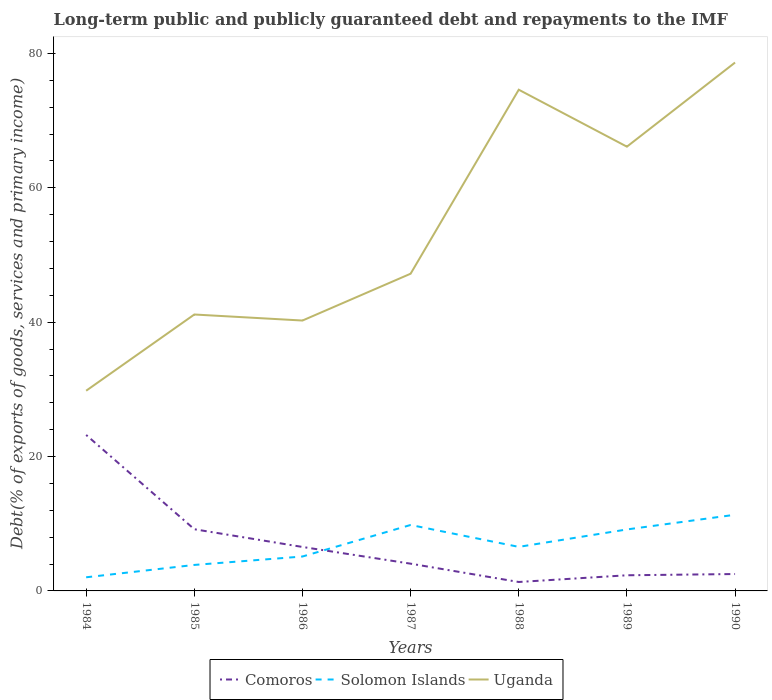How many different coloured lines are there?
Offer a very short reply. 3. Does the line corresponding to Uganda intersect with the line corresponding to Comoros?
Keep it short and to the point. No. Is the number of lines equal to the number of legend labels?
Give a very brief answer. Yes. Across all years, what is the maximum debt and repayments in Uganda?
Offer a very short reply. 29.8. In which year was the debt and repayments in Solomon Islands maximum?
Offer a very short reply. 1984. What is the total debt and repayments in Comoros in the graph?
Your answer should be very brief. 14.03. What is the difference between the highest and the second highest debt and repayments in Solomon Islands?
Ensure brevity in your answer.  9.31. What is the difference between two consecutive major ticks on the Y-axis?
Ensure brevity in your answer.  20. Are the values on the major ticks of Y-axis written in scientific E-notation?
Offer a very short reply. No. Does the graph contain grids?
Ensure brevity in your answer.  No. What is the title of the graph?
Keep it short and to the point. Long-term public and publicly guaranteed debt and repayments to the IMF. What is the label or title of the Y-axis?
Make the answer very short. Debt(% of exports of goods, services and primary income). What is the Debt(% of exports of goods, services and primary income) of Comoros in 1984?
Keep it short and to the point. 23.21. What is the Debt(% of exports of goods, services and primary income) in Solomon Islands in 1984?
Offer a very short reply. 2.03. What is the Debt(% of exports of goods, services and primary income) in Uganda in 1984?
Your response must be concise. 29.8. What is the Debt(% of exports of goods, services and primary income) in Comoros in 1985?
Provide a succinct answer. 9.18. What is the Debt(% of exports of goods, services and primary income) of Solomon Islands in 1985?
Keep it short and to the point. 3.87. What is the Debt(% of exports of goods, services and primary income) of Uganda in 1985?
Your answer should be very brief. 41.14. What is the Debt(% of exports of goods, services and primary income) of Comoros in 1986?
Offer a very short reply. 6.54. What is the Debt(% of exports of goods, services and primary income) of Solomon Islands in 1986?
Make the answer very short. 5.12. What is the Debt(% of exports of goods, services and primary income) of Uganda in 1986?
Your answer should be very brief. 40.24. What is the Debt(% of exports of goods, services and primary income) in Comoros in 1987?
Give a very brief answer. 4.06. What is the Debt(% of exports of goods, services and primary income) in Solomon Islands in 1987?
Your answer should be compact. 9.82. What is the Debt(% of exports of goods, services and primary income) of Uganda in 1987?
Provide a short and direct response. 47.21. What is the Debt(% of exports of goods, services and primary income) of Comoros in 1988?
Make the answer very short. 1.33. What is the Debt(% of exports of goods, services and primary income) of Solomon Islands in 1988?
Your answer should be very brief. 6.56. What is the Debt(% of exports of goods, services and primary income) in Uganda in 1988?
Provide a short and direct response. 74.6. What is the Debt(% of exports of goods, services and primary income) of Comoros in 1989?
Provide a succinct answer. 2.33. What is the Debt(% of exports of goods, services and primary income) in Solomon Islands in 1989?
Provide a short and direct response. 9.15. What is the Debt(% of exports of goods, services and primary income) of Uganda in 1989?
Offer a very short reply. 66.12. What is the Debt(% of exports of goods, services and primary income) of Comoros in 1990?
Provide a succinct answer. 2.51. What is the Debt(% of exports of goods, services and primary income) of Solomon Islands in 1990?
Keep it short and to the point. 11.34. What is the Debt(% of exports of goods, services and primary income) of Uganda in 1990?
Your answer should be compact. 78.64. Across all years, what is the maximum Debt(% of exports of goods, services and primary income) in Comoros?
Your response must be concise. 23.21. Across all years, what is the maximum Debt(% of exports of goods, services and primary income) of Solomon Islands?
Your answer should be very brief. 11.34. Across all years, what is the maximum Debt(% of exports of goods, services and primary income) in Uganda?
Offer a terse response. 78.64. Across all years, what is the minimum Debt(% of exports of goods, services and primary income) in Comoros?
Make the answer very short. 1.33. Across all years, what is the minimum Debt(% of exports of goods, services and primary income) of Solomon Islands?
Your answer should be very brief. 2.03. Across all years, what is the minimum Debt(% of exports of goods, services and primary income) in Uganda?
Provide a short and direct response. 29.8. What is the total Debt(% of exports of goods, services and primary income) of Comoros in the graph?
Make the answer very short. 49.16. What is the total Debt(% of exports of goods, services and primary income) of Solomon Islands in the graph?
Ensure brevity in your answer.  47.87. What is the total Debt(% of exports of goods, services and primary income) in Uganda in the graph?
Provide a succinct answer. 377.74. What is the difference between the Debt(% of exports of goods, services and primary income) in Comoros in 1984 and that in 1985?
Keep it short and to the point. 14.03. What is the difference between the Debt(% of exports of goods, services and primary income) of Solomon Islands in 1984 and that in 1985?
Your response must be concise. -1.84. What is the difference between the Debt(% of exports of goods, services and primary income) of Uganda in 1984 and that in 1985?
Offer a terse response. -11.34. What is the difference between the Debt(% of exports of goods, services and primary income) in Comoros in 1984 and that in 1986?
Make the answer very short. 16.67. What is the difference between the Debt(% of exports of goods, services and primary income) in Solomon Islands in 1984 and that in 1986?
Ensure brevity in your answer.  -3.09. What is the difference between the Debt(% of exports of goods, services and primary income) of Uganda in 1984 and that in 1986?
Offer a very short reply. -10.45. What is the difference between the Debt(% of exports of goods, services and primary income) of Comoros in 1984 and that in 1987?
Ensure brevity in your answer.  19.16. What is the difference between the Debt(% of exports of goods, services and primary income) in Solomon Islands in 1984 and that in 1987?
Ensure brevity in your answer.  -7.79. What is the difference between the Debt(% of exports of goods, services and primary income) in Uganda in 1984 and that in 1987?
Make the answer very short. -17.42. What is the difference between the Debt(% of exports of goods, services and primary income) in Comoros in 1984 and that in 1988?
Offer a very short reply. 21.88. What is the difference between the Debt(% of exports of goods, services and primary income) in Solomon Islands in 1984 and that in 1988?
Provide a succinct answer. -4.53. What is the difference between the Debt(% of exports of goods, services and primary income) in Uganda in 1984 and that in 1988?
Keep it short and to the point. -44.8. What is the difference between the Debt(% of exports of goods, services and primary income) in Comoros in 1984 and that in 1989?
Your answer should be very brief. 20.88. What is the difference between the Debt(% of exports of goods, services and primary income) of Solomon Islands in 1984 and that in 1989?
Offer a very short reply. -7.12. What is the difference between the Debt(% of exports of goods, services and primary income) of Uganda in 1984 and that in 1989?
Provide a short and direct response. -36.32. What is the difference between the Debt(% of exports of goods, services and primary income) of Comoros in 1984 and that in 1990?
Your answer should be very brief. 20.7. What is the difference between the Debt(% of exports of goods, services and primary income) of Solomon Islands in 1984 and that in 1990?
Your answer should be compact. -9.31. What is the difference between the Debt(% of exports of goods, services and primary income) in Uganda in 1984 and that in 1990?
Keep it short and to the point. -48.84. What is the difference between the Debt(% of exports of goods, services and primary income) in Comoros in 1985 and that in 1986?
Provide a short and direct response. 2.64. What is the difference between the Debt(% of exports of goods, services and primary income) in Solomon Islands in 1985 and that in 1986?
Make the answer very short. -1.25. What is the difference between the Debt(% of exports of goods, services and primary income) of Uganda in 1985 and that in 1986?
Keep it short and to the point. 0.9. What is the difference between the Debt(% of exports of goods, services and primary income) of Comoros in 1985 and that in 1987?
Make the answer very short. 5.12. What is the difference between the Debt(% of exports of goods, services and primary income) of Solomon Islands in 1985 and that in 1987?
Offer a very short reply. -5.95. What is the difference between the Debt(% of exports of goods, services and primary income) in Uganda in 1985 and that in 1987?
Your response must be concise. -6.07. What is the difference between the Debt(% of exports of goods, services and primary income) of Comoros in 1985 and that in 1988?
Offer a terse response. 7.85. What is the difference between the Debt(% of exports of goods, services and primary income) in Solomon Islands in 1985 and that in 1988?
Offer a terse response. -2.69. What is the difference between the Debt(% of exports of goods, services and primary income) in Uganda in 1985 and that in 1988?
Your answer should be compact. -33.46. What is the difference between the Debt(% of exports of goods, services and primary income) of Comoros in 1985 and that in 1989?
Keep it short and to the point. 6.85. What is the difference between the Debt(% of exports of goods, services and primary income) in Solomon Islands in 1985 and that in 1989?
Give a very brief answer. -5.28. What is the difference between the Debt(% of exports of goods, services and primary income) in Uganda in 1985 and that in 1989?
Provide a succinct answer. -24.98. What is the difference between the Debt(% of exports of goods, services and primary income) of Comoros in 1985 and that in 1990?
Provide a short and direct response. 6.67. What is the difference between the Debt(% of exports of goods, services and primary income) of Solomon Islands in 1985 and that in 1990?
Your answer should be very brief. -7.47. What is the difference between the Debt(% of exports of goods, services and primary income) in Uganda in 1985 and that in 1990?
Your answer should be very brief. -37.5. What is the difference between the Debt(% of exports of goods, services and primary income) of Comoros in 1986 and that in 1987?
Keep it short and to the point. 2.49. What is the difference between the Debt(% of exports of goods, services and primary income) of Solomon Islands in 1986 and that in 1987?
Your answer should be compact. -4.69. What is the difference between the Debt(% of exports of goods, services and primary income) in Uganda in 1986 and that in 1987?
Your answer should be very brief. -6.97. What is the difference between the Debt(% of exports of goods, services and primary income) in Comoros in 1986 and that in 1988?
Offer a very short reply. 5.21. What is the difference between the Debt(% of exports of goods, services and primary income) of Solomon Islands in 1986 and that in 1988?
Provide a short and direct response. -1.43. What is the difference between the Debt(% of exports of goods, services and primary income) in Uganda in 1986 and that in 1988?
Your answer should be very brief. -34.35. What is the difference between the Debt(% of exports of goods, services and primary income) of Comoros in 1986 and that in 1989?
Keep it short and to the point. 4.21. What is the difference between the Debt(% of exports of goods, services and primary income) in Solomon Islands in 1986 and that in 1989?
Your answer should be compact. -4.03. What is the difference between the Debt(% of exports of goods, services and primary income) of Uganda in 1986 and that in 1989?
Provide a succinct answer. -25.88. What is the difference between the Debt(% of exports of goods, services and primary income) in Comoros in 1986 and that in 1990?
Provide a short and direct response. 4.03. What is the difference between the Debt(% of exports of goods, services and primary income) of Solomon Islands in 1986 and that in 1990?
Give a very brief answer. -6.22. What is the difference between the Debt(% of exports of goods, services and primary income) in Uganda in 1986 and that in 1990?
Your response must be concise. -38.4. What is the difference between the Debt(% of exports of goods, services and primary income) of Comoros in 1987 and that in 1988?
Offer a terse response. 2.73. What is the difference between the Debt(% of exports of goods, services and primary income) of Solomon Islands in 1987 and that in 1988?
Offer a terse response. 3.26. What is the difference between the Debt(% of exports of goods, services and primary income) of Uganda in 1987 and that in 1988?
Your answer should be compact. -27.39. What is the difference between the Debt(% of exports of goods, services and primary income) in Comoros in 1987 and that in 1989?
Your answer should be very brief. 1.73. What is the difference between the Debt(% of exports of goods, services and primary income) in Solomon Islands in 1987 and that in 1989?
Your answer should be very brief. 0.67. What is the difference between the Debt(% of exports of goods, services and primary income) of Uganda in 1987 and that in 1989?
Make the answer very short. -18.91. What is the difference between the Debt(% of exports of goods, services and primary income) of Comoros in 1987 and that in 1990?
Keep it short and to the point. 1.54. What is the difference between the Debt(% of exports of goods, services and primary income) of Solomon Islands in 1987 and that in 1990?
Keep it short and to the point. -1.52. What is the difference between the Debt(% of exports of goods, services and primary income) in Uganda in 1987 and that in 1990?
Provide a succinct answer. -31.43. What is the difference between the Debt(% of exports of goods, services and primary income) of Comoros in 1988 and that in 1989?
Your response must be concise. -1. What is the difference between the Debt(% of exports of goods, services and primary income) of Solomon Islands in 1988 and that in 1989?
Offer a terse response. -2.59. What is the difference between the Debt(% of exports of goods, services and primary income) in Uganda in 1988 and that in 1989?
Make the answer very short. 8.48. What is the difference between the Debt(% of exports of goods, services and primary income) of Comoros in 1988 and that in 1990?
Ensure brevity in your answer.  -1.18. What is the difference between the Debt(% of exports of goods, services and primary income) of Solomon Islands in 1988 and that in 1990?
Offer a very short reply. -4.78. What is the difference between the Debt(% of exports of goods, services and primary income) of Uganda in 1988 and that in 1990?
Offer a terse response. -4.04. What is the difference between the Debt(% of exports of goods, services and primary income) of Comoros in 1989 and that in 1990?
Your answer should be very brief. -0.19. What is the difference between the Debt(% of exports of goods, services and primary income) in Solomon Islands in 1989 and that in 1990?
Provide a succinct answer. -2.19. What is the difference between the Debt(% of exports of goods, services and primary income) of Uganda in 1989 and that in 1990?
Offer a terse response. -12.52. What is the difference between the Debt(% of exports of goods, services and primary income) in Comoros in 1984 and the Debt(% of exports of goods, services and primary income) in Solomon Islands in 1985?
Your answer should be very brief. 19.34. What is the difference between the Debt(% of exports of goods, services and primary income) in Comoros in 1984 and the Debt(% of exports of goods, services and primary income) in Uganda in 1985?
Your answer should be compact. -17.93. What is the difference between the Debt(% of exports of goods, services and primary income) of Solomon Islands in 1984 and the Debt(% of exports of goods, services and primary income) of Uganda in 1985?
Provide a short and direct response. -39.11. What is the difference between the Debt(% of exports of goods, services and primary income) in Comoros in 1984 and the Debt(% of exports of goods, services and primary income) in Solomon Islands in 1986?
Provide a succinct answer. 18.09. What is the difference between the Debt(% of exports of goods, services and primary income) in Comoros in 1984 and the Debt(% of exports of goods, services and primary income) in Uganda in 1986?
Your response must be concise. -17.03. What is the difference between the Debt(% of exports of goods, services and primary income) in Solomon Islands in 1984 and the Debt(% of exports of goods, services and primary income) in Uganda in 1986?
Your answer should be very brief. -38.21. What is the difference between the Debt(% of exports of goods, services and primary income) of Comoros in 1984 and the Debt(% of exports of goods, services and primary income) of Solomon Islands in 1987?
Offer a very short reply. 13.4. What is the difference between the Debt(% of exports of goods, services and primary income) of Comoros in 1984 and the Debt(% of exports of goods, services and primary income) of Uganda in 1987?
Offer a very short reply. -24. What is the difference between the Debt(% of exports of goods, services and primary income) of Solomon Islands in 1984 and the Debt(% of exports of goods, services and primary income) of Uganda in 1987?
Provide a succinct answer. -45.18. What is the difference between the Debt(% of exports of goods, services and primary income) of Comoros in 1984 and the Debt(% of exports of goods, services and primary income) of Solomon Islands in 1988?
Keep it short and to the point. 16.66. What is the difference between the Debt(% of exports of goods, services and primary income) in Comoros in 1984 and the Debt(% of exports of goods, services and primary income) in Uganda in 1988?
Offer a very short reply. -51.38. What is the difference between the Debt(% of exports of goods, services and primary income) in Solomon Islands in 1984 and the Debt(% of exports of goods, services and primary income) in Uganda in 1988?
Your response must be concise. -72.57. What is the difference between the Debt(% of exports of goods, services and primary income) of Comoros in 1984 and the Debt(% of exports of goods, services and primary income) of Solomon Islands in 1989?
Provide a short and direct response. 14.06. What is the difference between the Debt(% of exports of goods, services and primary income) in Comoros in 1984 and the Debt(% of exports of goods, services and primary income) in Uganda in 1989?
Give a very brief answer. -42.91. What is the difference between the Debt(% of exports of goods, services and primary income) in Solomon Islands in 1984 and the Debt(% of exports of goods, services and primary income) in Uganda in 1989?
Provide a succinct answer. -64.09. What is the difference between the Debt(% of exports of goods, services and primary income) in Comoros in 1984 and the Debt(% of exports of goods, services and primary income) in Solomon Islands in 1990?
Provide a succinct answer. 11.88. What is the difference between the Debt(% of exports of goods, services and primary income) in Comoros in 1984 and the Debt(% of exports of goods, services and primary income) in Uganda in 1990?
Offer a very short reply. -55.43. What is the difference between the Debt(% of exports of goods, services and primary income) in Solomon Islands in 1984 and the Debt(% of exports of goods, services and primary income) in Uganda in 1990?
Provide a short and direct response. -76.61. What is the difference between the Debt(% of exports of goods, services and primary income) in Comoros in 1985 and the Debt(% of exports of goods, services and primary income) in Solomon Islands in 1986?
Offer a very short reply. 4.06. What is the difference between the Debt(% of exports of goods, services and primary income) of Comoros in 1985 and the Debt(% of exports of goods, services and primary income) of Uganda in 1986?
Your answer should be very brief. -31.06. What is the difference between the Debt(% of exports of goods, services and primary income) in Solomon Islands in 1985 and the Debt(% of exports of goods, services and primary income) in Uganda in 1986?
Give a very brief answer. -36.37. What is the difference between the Debt(% of exports of goods, services and primary income) of Comoros in 1985 and the Debt(% of exports of goods, services and primary income) of Solomon Islands in 1987?
Ensure brevity in your answer.  -0.63. What is the difference between the Debt(% of exports of goods, services and primary income) in Comoros in 1985 and the Debt(% of exports of goods, services and primary income) in Uganda in 1987?
Your answer should be very brief. -38.03. What is the difference between the Debt(% of exports of goods, services and primary income) in Solomon Islands in 1985 and the Debt(% of exports of goods, services and primary income) in Uganda in 1987?
Provide a short and direct response. -43.34. What is the difference between the Debt(% of exports of goods, services and primary income) in Comoros in 1985 and the Debt(% of exports of goods, services and primary income) in Solomon Islands in 1988?
Offer a terse response. 2.62. What is the difference between the Debt(% of exports of goods, services and primary income) of Comoros in 1985 and the Debt(% of exports of goods, services and primary income) of Uganda in 1988?
Make the answer very short. -65.42. What is the difference between the Debt(% of exports of goods, services and primary income) in Solomon Islands in 1985 and the Debt(% of exports of goods, services and primary income) in Uganda in 1988?
Provide a short and direct response. -70.73. What is the difference between the Debt(% of exports of goods, services and primary income) in Comoros in 1985 and the Debt(% of exports of goods, services and primary income) in Solomon Islands in 1989?
Make the answer very short. 0.03. What is the difference between the Debt(% of exports of goods, services and primary income) in Comoros in 1985 and the Debt(% of exports of goods, services and primary income) in Uganda in 1989?
Provide a short and direct response. -56.94. What is the difference between the Debt(% of exports of goods, services and primary income) of Solomon Islands in 1985 and the Debt(% of exports of goods, services and primary income) of Uganda in 1989?
Offer a very short reply. -62.25. What is the difference between the Debt(% of exports of goods, services and primary income) of Comoros in 1985 and the Debt(% of exports of goods, services and primary income) of Solomon Islands in 1990?
Offer a terse response. -2.16. What is the difference between the Debt(% of exports of goods, services and primary income) of Comoros in 1985 and the Debt(% of exports of goods, services and primary income) of Uganda in 1990?
Make the answer very short. -69.46. What is the difference between the Debt(% of exports of goods, services and primary income) in Solomon Islands in 1985 and the Debt(% of exports of goods, services and primary income) in Uganda in 1990?
Your answer should be compact. -74.77. What is the difference between the Debt(% of exports of goods, services and primary income) in Comoros in 1986 and the Debt(% of exports of goods, services and primary income) in Solomon Islands in 1987?
Offer a very short reply. -3.27. What is the difference between the Debt(% of exports of goods, services and primary income) in Comoros in 1986 and the Debt(% of exports of goods, services and primary income) in Uganda in 1987?
Keep it short and to the point. -40.67. What is the difference between the Debt(% of exports of goods, services and primary income) of Solomon Islands in 1986 and the Debt(% of exports of goods, services and primary income) of Uganda in 1987?
Keep it short and to the point. -42.09. What is the difference between the Debt(% of exports of goods, services and primary income) of Comoros in 1986 and the Debt(% of exports of goods, services and primary income) of Solomon Islands in 1988?
Ensure brevity in your answer.  -0.01. What is the difference between the Debt(% of exports of goods, services and primary income) in Comoros in 1986 and the Debt(% of exports of goods, services and primary income) in Uganda in 1988?
Your response must be concise. -68.05. What is the difference between the Debt(% of exports of goods, services and primary income) in Solomon Islands in 1986 and the Debt(% of exports of goods, services and primary income) in Uganda in 1988?
Your answer should be very brief. -69.48. What is the difference between the Debt(% of exports of goods, services and primary income) of Comoros in 1986 and the Debt(% of exports of goods, services and primary income) of Solomon Islands in 1989?
Ensure brevity in your answer.  -2.61. What is the difference between the Debt(% of exports of goods, services and primary income) in Comoros in 1986 and the Debt(% of exports of goods, services and primary income) in Uganda in 1989?
Your answer should be compact. -59.58. What is the difference between the Debt(% of exports of goods, services and primary income) of Solomon Islands in 1986 and the Debt(% of exports of goods, services and primary income) of Uganda in 1989?
Offer a very short reply. -61. What is the difference between the Debt(% of exports of goods, services and primary income) of Comoros in 1986 and the Debt(% of exports of goods, services and primary income) of Solomon Islands in 1990?
Make the answer very short. -4.79. What is the difference between the Debt(% of exports of goods, services and primary income) in Comoros in 1986 and the Debt(% of exports of goods, services and primary income) in Uganda in 1990?
Give a very brief answer. -72.1. What is the difference between the Debt(% of exports of goods, services and primary income) of Solomon Islands in 1986 and the Debt(% of exports of goods, services and primary income) of Uganda in 1990?
Your answer should be compact. -73.52. What is the difference between the Debt(% of exports of goods, services and primary income) of Comoros in 1987 and the Debt(% of exports of goods, services and primary income) of Solomon Islands in 1988?
Provide a succinct answer. -2.5. What is the difference between the Debt(% of exports of goods, services and primary income) of Comoros in 1987 and the Debt(% of exports of goods, services and primary income) of Uganda in 1988?
Make the answer very short. -70.54. What is the difference between the Debt(% of exports of goods, services and primary income) of Solomon Islands in 1987 and the Debt(% of exports of goods, services and primary income) of Uganda in 1988?
Offer a terse response. -64.78. What is the difference between the Debt(% of exports of goods, services and primary income) of Comoros in 1987 and the Debt(% of exports of goods, services and primary income) of Solomon Islands in 1989?
Offer a terse response. -5.09. What is the difference between the Debt(% of exports of goods, services and primary income) in Comoros in 1987 and the Debt(% of exports of goods, services and primary income) in Uganda in 1989?
Make the answer very short. -62.06. What is the difference between the Debt(% of exports of goods, services and primary income) in Solomon Islands in 1987 and the Debt(% of exports of goods, services and primary income) in Uganda in 1989?
Keep it short and to the point. -56.3. What is the difference between the Debt(% of exports of goods, services and primary income) of Comoros in 1987 and the Debt(% of exports of goods, services and primary income) of Solomon Islands in 1990?
Offer a terse response. -7.28. What is the difference between the Debt(% of exports of goods, services and primary income) of Comoros in 1987 and the Debt(% of exports of goods, services and primary income) of Uganda in 1990?
Your answer should be very brief. -74.58. What is the difference between the Debt(% of exports of goods, services and primary income) of Solomon Islands in 1987 and the Debt(% of exports of goods, services and primary income) of Uganda in 1990?
Ensure brevity in your answer.  -68.82. What is the difference between the Debt(% of exports of goods, services and primary income) of Comoros in 1988 and the Debt(% of exports of goods, services and primary income) of Solomon Islands in 1989?
Ensure brevity in your answer.  -7.82. What is the difference between the Debt(% of exports of goods, services and primary income) of Comoros in 1988 and the Debt(% of exports of goods, services and primary income) of Uganda in 1989?
Provide a short and direct response. -64.79. What is the difference between the Debt(% of exports of goods, services and primary income) in Solomon Islands in 1988 and the Debt(% of exports of goods, services and primary income) in Uganda in 1989?
Make the answer very short. -59.56. What is the difference between the Debt(% of exports of goods, services and primary income) in Comoros in 1988 and the Debt(% of exports of goods, services and primary income) in Solomon Islands in 1990?
Make the answer very short. -10.01. What is the difference between the Debt(% of exports of goods, services and primary income) in Comoros in 1988 and the Debt(% of exports of goods, services and primary income) in Uganda in 1990?
Give a very brief answer. -77.31. What is the difference between the Debt(% of exports of goods, services and primary income) of Solomon Islands in 1988 and the Debt(% of exports of goods, services and primary income) of Uganda in 1990?
Offer a very short reply. -72.08. What is the difference between the Debt(% of exports of goods, services and primary income) in Comoros in 1989 and the Debt(% of exports of goods, services and primary income) in Solomon Islands in 1990?
Your response must be concise. -9.01. What is the difference between the Debt(% of exports of goods, services and primary income) in Comoros in 1989 and the Debt(% of exports of goods, services and primary income) in Uganda in 1990?
Make the answer very short. -76.31. What is the difference between the Debt(% of exports of goods, services and primary income) in Solomon Islands in 1989 and the Debt(% of exports of goods, services and primary income) in Uganda in 1990?
Provide a succinct answer. -69.49. What is the average Debt(% of exports of goods, services and primary income) in Comoros per year?
Your answer should be compact. 7.02. What is the average Debt(% of exports of goods, services and primary income) in Solomon Islands per year?
Your answer should be very brief. 6.84. What is the average Debt(% of exports of goods, services and primary income) of Uganda per year?
Ensure brevity in your answer.  53.96. In the year 1984, what is the difference between the Debt(% of exports of goods, services and primary income) in Comoros and Debt(% of exports of goods, services and primary income) in Solomon Islands?
Offer a very short reply. 21.18. In the year 1984, what is the difference between the Debt(% of exports of goods, services and primary income) in Comoros and Debt(% of exports of goods, services and primary income) in Uganda?
Offer a terse response. -6.58. In the year 1984, what is the difference between the Debt(% of exports of goods, services and primary income) of Solomon Islands and Debt(% of exports of goods, services and primary income) of Uganda?
Offer a very short reply. -27.77. In the year 1985, what is the difference between the Debt(% of exports of goods, services and primary income) in Comoros and Debt(% of exports of goods, services and primary income) in Solomon Islands?
Provide a succinct answer. 5.31. In the year 1985, what is the difference between the Debt(% of exports of goods, services and primary income) in Comoros and Debt(% of exports of goods, services and primary income) in Uganda?
Your answer should be very brief. -31.96. In the year 1985, what is the difference between the Debt(% of exports of goods, services and primary income) of Solomon Islands and Debt(% of exports of goods, services and primary income) of Uganda?
Your answer should be very brief. -37.27. In the year 1986, what is the difference between the Debt(% of exports of goods, services and primary income) in Comoros and Debt(% of exports of goods, services and primary income) in Solomon Islands?
Your response must be concise. 1.42. In the year 1986, what is the difference between the Debt(% of exports of goods, services and primary income) in Comoros and Debt(% of exports of goods, services and primary income) in Uganda?
Your answer should be very brief. -33.7. In the year 1986, what is the difference between the Debt(% of exports of goods, services and primary income) of Solomon Islands and Debt(% of exports of goods, services and primary income) of Uganda?
Provide a short and direct response. -35.12. In the year 1987, what is the difference between the Debt(% of exports of goods, services and primary income) in Comoros and Debt(% of exports of goods, services and primary income) in Solomon Islands?
Ensure brevity in your answer.  -5.76. In the year 1987, what is the difference between the Debt(% of exports of goods, services and primary income) of Comoros and Debt(% of exports of goods, services and primary income) of Uganda?
Provide a short and direct response. -43.16. In the year 1987, what is the difference between the Debt(% of exports of goods, services and primary income) of Solomon Islands and Debt(% of exports of goods, services and primary income) of Uganda?
Your answer should be very brief. -37.4. In the year 1988, what is the difference between the Debt(% of exports of goods, services and primary income) of Comoros and Debt(% of exports of goods, services and primary income) of Solomon Islands?
Offer a terse response. -5.23. In the year 1988, what is the difference between the Debt(% of exports of goods, services and primary income) in Comoros and Debt(% of exports of goods, services and primary income) in Uganda?
Your response must be concise. -73.27. In the year 1988, what is the difference between the Debt(% of exports of goods, services and primary income) of Solomon Islands and Debt(% of exports of goods, services and primary income) of Uganda?
Offer a very short reply. -68.04. In the year 1989, what is the difference between the Debt(% of exports of goods, services and primary income) in Comoros and Debt(% of exports of goods, services and primary income) in Solomon Islands?
Keep it short and to the point. -6.82. In the year 1989, what is the difference between the Debt(% of exports of goods, services and primary income) of Comoros and Debt(% of exports of goods, services and primary income) of Uganda?
Ensure brevity in your answer.  -63.79. In the year 1989, what is the difference between the Debt(% of exports of goods, services and primary income) of Solomon Islands and Debt(% of exports of goods, services and primary income) of Uganda?
Your answer should be very brief. -56.97. In the year 1990, what is the difference between the Debt(% of exports of goods, services and primary income) of Comoros and Debt(% of exports of goods, services and primary income) of Solomon Islands?
Keep it short and to the point. -8.82. In the year 1990, what is the difference between the Debt(% of exports of goods, services and primary income) in Comoros and Debt(% of exports of goods, services and primary income) in Uganda?
Give a very brief answer. -76.12. In the year 1990, what is the difference between the Debt(% of exports of goods, services and primary income) in Solomon Islands and Debt(% of exports of goods, services and primary income) in Uganda?
Offer a very short reply. -67.3. What is the ratio of the Debt(% of exports of goods, services and primary income) of Comoros in 1984 to that in 1985?
Your answer should be compact. 2.53. What is the ratio of the Debt(% of exports of goods, services and primary income) of Solomon Islands in 1984 to that in 1985?
Give a very brief answer. 0.52. What is the ratio of the Debt(% of exports of goods, services and primary income) in Uganda in 1984 to that in 1985?
Your answer should be very brief. 0.72. What is the ratio of the Debt(% of exports of goods, services and primary income) of Comoros in 1984 to that in 1986?
Offer a very short reply. 3.55. What is the ratio of the Debt(% of exports of goods, services and primary income) of Solomon Islands in 1984 to that in 1986?
Provide a succinct answer. 0.4. What is the ratio of the Debt(% of exports of goods, services and primary income) of Uganda in 1984 to that in 1986?
Ensure brevity in your answer.  0.74. What is the ratio of the Debt(% of exports of goods, services and primary income) of Comoros in 1984 to that in 1987?
Your answer should be very brief. 5.72. What is the ratio of the Debt(% of exports of goods, services and primary income) of Solomon Islands in 1984 to that in 1987?
Give a very brief answer. 0.21. What is the ratio of the Debt(% of exports of goods, services and primary income) of Uganda in 1984 to that in 1987?
Your response must be concise. 0.63. What is the ratio of the Debt(% of exports of goods, services and primary income) of Comoros in 1984 to that in 1988?
Your response must be concise. 17.46. What is the ratio of the Debt(% of exports of goods, services and primary income) of Solomon Islands in 1984 to that in 1988?
Offer a very short reply. 0.31. What is the ratio of the Debt(% of exports of goods, services and primary income) of Uganda in 1984 to that in 1988?
Offer a very short reply. 0.4. What is the ratio of the Debt(% of exports of goods, services and primary income) of Comoros in 1984 to that in 1989?
Your response must be concise. 9.97. What is the ratio of the Debt(% of exports of goods, services and primary income) of Solomon Islands in 1984 to that in 1989?
Keep it short and to the point. 0.22. What is the ratio of the Debt(% of exports of goods, services and primary income) in Uganda in 1984 to that in 1989?
Offer a terse response. 0.45. What is the ratio of the Debt(% of exports of goods, services and primary income) in Comoros in 1984 to that in 1990?
Offer a terse response. 9.23. What is the ratio of the Debt(% of exports of goods, services and primary income) in Solomon Islands in 1984 to that in 1990?
Give a very brief answer. 0.18. What is the ratio of the Debt(% of exports of goods, services and primary income) in Uganda in 1984 to that in 1990?
Your response must be concise. 0.38. What is the ratio of the Debt(% of exports of goods, services and primary income) in Comoros in 1985 to that in 1986?
Your answer should be compact. 1.4. What is the ratio of the Debt(% of exports of goods, services and primary income) of Solomon Islands in 1985 to that in 1986?
Offer a terse response. 0.76. What is the ratio of the Debt(% of exports of goods, services and primary income) of Uganda in 1985 to that in 1986?
Keep it short and to the point. 1.02. What is the ratio of the Debt(% of exports of goods, services and primary income) of Comoros in 1985 to that in 1987?
Provide a succinct answer. 2.26. What is the ratio of the Debt(% of exports of goods, services and primary income) of Solomon Islands in 1985 to that in 1987?
Your answer should be compact. 0.39. What is the ratio of the Debt(% of exports of goods, services and primary income) of Uganda in 1985 to that in 1987?
Ensure brevity in your answer.  0.87. What is the ratio of the Debt(% of exports of goods, services and primary income) in Comoros in 1985 to that in 1988?
Offer a terse response. 6.91. What is the ratio of the Debt(% of exports of goods, services and primary income) in Solomon Islands in 1985 to that in 1988?
Your response must be concise. 0.59. What is the ratio of the Debt(% of exports of goods, services and primary income) in Uganda in 1985 to that in 1988?
Your answer should be compact. 0.55. What is the ratio of the Debt(% of exports of goods, services and primary income) of Comoros in 1985 to that in 1989?
Offer a very short reply. 3.94. What is the ratio of the Debt(% of exports of goods, services and primary income) in Solomon Islands in 1985 to that in 1989?
Your answer should be compact. 0.42. What is the ratio of the Debt(% of exports of goods, services and primary income) of Uganda in 1985 to that in 1989?
Your answer should be very brief. 0.62. What is the ratio of the Debt(% of exports of goods, services and primary income) of Comoros in 1985 to that in 1990?
Your answer should be very brief. 3.65. What is the ratio of the Debt(% of exports of goods, services and primary income) in Solomon Islands in 1985 to that in 1990?
Keep it short and to the point. 0.34. What is the ratio of the Debt(% of exports of goods, services and primary income) of Uganda in 1985 to that in 1990?
Your answer should be very brief. 0.52. What is the ratio of the Debt(% of exports of goods, services and primary income) in Comoros in 1986 to that in 1987?
Offer a terse response. 1.61. What is the ratio of the Debt(% of exports of goods, services and primary income) of Solomon Islands in 1986 to that in 1987?
Offer a terse response. 0.52. What is the ratio of the Debt(% of exports of goods, services and primary income) of Uganda in 1986 to that in 1987?
Your answer should be very brief. 0.85. What is the ratio of the Debt(% of exports of goods, services and primary income) of Comoros in 1986 to that in 1988?
Offer a very short reply. 4.92. What is the ratio of the Debt(% of exports of goods, services and primary income) of Solomon Islands in 1986 to that in 1988?
Offer a very short reply. 0.78. What is the ratio of the Debt(% of exports of goods, services and primary income) in Uganda in 1986 to that in 1988?
Your answer should be compact. 0.54. What is the ratio of the Debt(% of exports of goods, services and primary income) of Comoros in 1986 to that in 1989?
Offer a very short reply. 2.81. What is the ratio of the Debt(% of exports of goods, services and primary income) in Solomon Islands in 1986 to that in 1989?
Provide a short and direct response. 0.56. What is the ratio of the Debt(% of exports of goods, services and primary income) of Uganda in 1986 to that in 1989?
Provide a short and direct response. 0.61. What is the ratio of the Debt(% of exports of goods, services and primary income) in Comoros in 1986 to that in 1990?
Make the answer very short. 2.6. What is the ratio of the Debt(% of exports of goods, services and primary income) in Solomon Islands in 1986 to that in 1990?
Your answer should be very brief. 0.45. What is the ratio of the Debt(% of exports of goods, services and primary income) of Uganda in 1986 to that in 1990?
Give a very brief answer. 0.51. What is the ratio of the Debt(% of exports of goods, services and primary income) in Comoros in 1987 to that in 1988?
Give a very brief answer. 3.05. What is the ratio of the Debt(% of exports of goods, services and primary income) in Solomon Islands in 1987 to that in 1988?
Your response must be concise. 1.5. What is the ratio of the Debt(% of exports of goods, services and primary income) of Uganda in 1987 to that in 1988?
Your answer should be very brief. 0.63. What is the ratio of the Debt(% of exports of goods, services and primary income) of Comoros in 1987 to that in 1989?
Your response must be concise. 1.74. What is the ratio of the Debt(% of exports of goods, services and primary income) of Solomon Islands in 1987 to that in 1989?
Offer a very short reply. 1.07. What is the ratio of the Debt(% of exports of goods, services and primary income) of Uganda in 1987 to that in 1989?
Your answer should be compact. 0.71. What is the ratio of the Debt(% of exports of goods, services and primary income) in Comoros in 1987 to that in 1990?
Ensure brevity in your answer.  1.61. What is the ratio of the Debt(% of exports of goods, services and primary income) of Solomon Islands in 1987 to that in 1990?
Your response must be concise. 0.87. What is the ratio of the Debt(% of exports of goods, services and primary income) of Uganda in 1987 to that in 1990?
Keep it short and to the point. 0.6. What is the ratio of the Debt(% of exports of goods, services and primary income) in Comoros in 1988 to that in 1989?
Give a very brief answer. 0.57. What is the ratio of the Debt(% of exports of goods, services and primary income) of Solomon Islands in 1988 to that in 1989?
Your answer should be compact. 0.72. What is the ratio of the Debt(% of exports of goods, services and primary income) of Uganda in 1988 to that in 1989?
Make the answer very short. 1.13. What is the ratio of the Debt(% of exports of goods, services and primary income) of Comoros in 1988 to that in 1990?
Keep it short and to the point. 0.53. What is the ratio of the Debt(% of exports of goods, services and primary income) of Solomon Islands in 1988 to that in 1990?
Offer a very short reply. 0.58. What is the ratio of the Debt(% of exports of goods, services and primary income) of Uganda in 1988 to that in 1990?
Offer a very short reply. 0.95. What is the ratio of the Debt(% of exports of goods, services and primary income) of Comoros in 1989 to that in 1990?
Provide a short and direct response. 0.93. What is the ratio of the Debt(% of exports of goods, services and primary income) in Solomon Islands in 1989 to that in 1990?
Keep it short and to the point. 0.81. What is the ratio of the Debt(% of exports of goods, services and primary income) of Uganda in 1989 to that in 1990?
Provide a succinct answer. 0.84. What is the difference between the highest and the second highest Debt(% of exports of goods, services and primary income) in Comoros?
Keep it short and to the point. 14.03. What is the difference between the highest and the second highest Debt(% of exports of goods, services and primary income) in Solomon Islands?
Provide a succinct answer. 1.52. What is the difference between the highest and the second highest Debt(% of exports of goods, services and primary income) in Uganda?
Keep it short and to the point. 4.04. What is the difference between the highest and the lowest Debt(% of exports of goods, services and primary income) of Comoros?
Provide a short and direct response. 21.88. What is the difference between the highest and the lowest Debt(% of exports of goods, services and primary income) in Solomon Islands?
Offer a terse response. 9.31. What is the difference between the highest and the lowest Debt(% of exports of goods, services and primary income) of Uganda?
Ensure brevity in your answer.  48.84. 